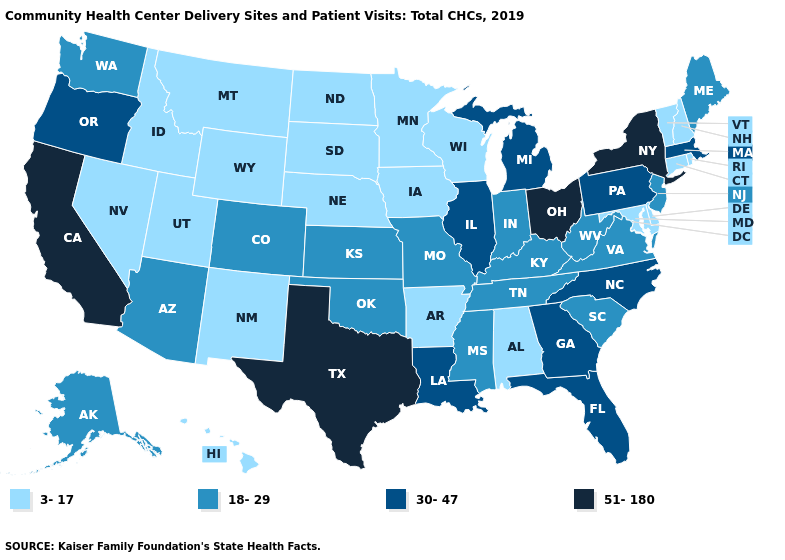Does Kansas have the lowest value in the MidWest?
Give a very brief answer. No. What is the value of Nebraska?
Concise answer only. 3-17. Among the states that border Nevada , does California have the lowest value?
Write a very short answer. No. Name the states that have a value in the range 51-180?
Concise answer only. California, New York, Ohio, Texas. What is the highest value in the Northeast ?
Quick response, please. 51-180. What is the value of South Dakota?
Quick response, please. 3-17. What is the value of Louisiana?
Keep it brief. 30-47. Which states hav the highest value in the MidWest?
Concise answer only. Ohio. Name the states that have a value in the range 3-17?
Keep it brief. Alabama, Arkansas, Connecticut, Delaware, Hawaii, Idaho, Iowa, Maryland, Minnesota, Montana, Nebraska, Nevada, New Hampshire, New Mexico, North Dakota, Rhode Island, South Dakota, Utah, Vermont, Wisconsin, Wyoming. Does the map have missing data?
Give a very brief answer. No. Name the states that have a value in the range 30-47?
Give a very brief answer. Florida, Georgia, Illinois, Louisiana, Massachusetts, Michigan, North Carolina, Oregon, Pennsylvania. What is the highest value in the Northeast ?
Quick response, please. 51-180. Does New Mexico have the lowest value in the USA?
Keep it brief. Yes. 